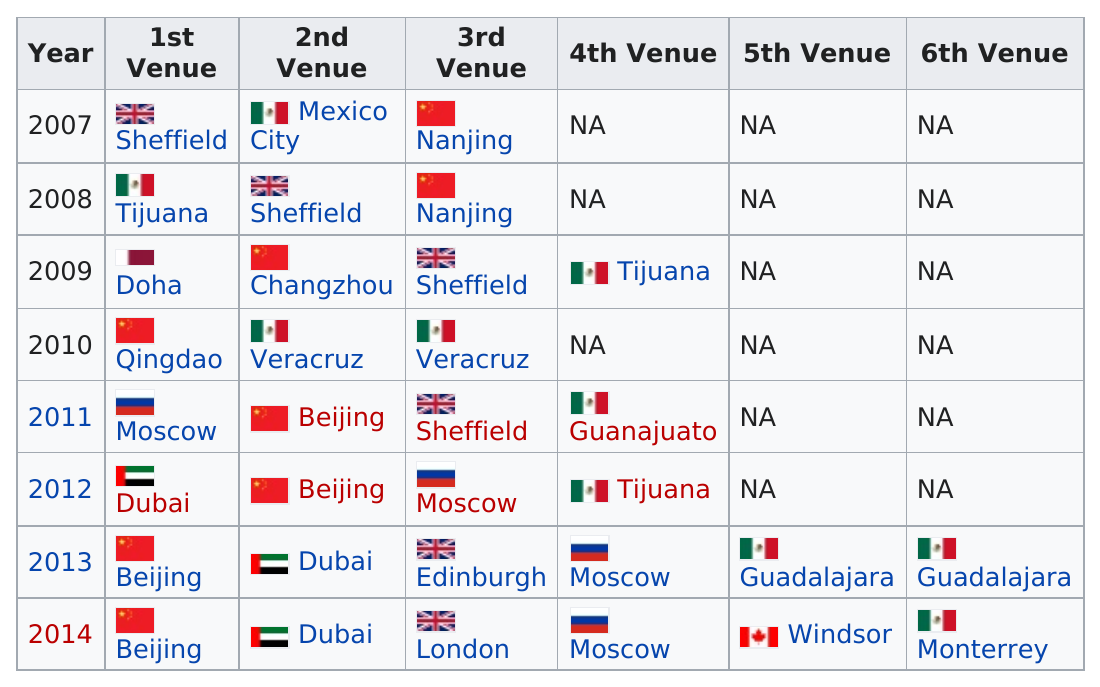Point out several critical features in this image. For the past seven years, the World Series has been taking place. The country with the most venues for its country is China. In the year 2012, Tijuana was a venue. In 2007, Mexico hosted the FIFA U-17 World Cup, making it the only year that the country has held the event. The previous year to 2011 is 2010. 